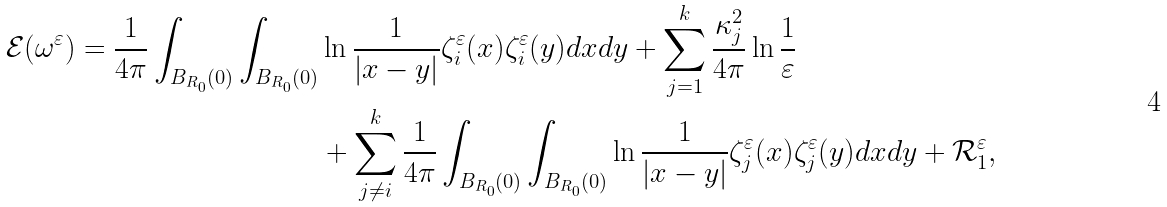Convert formula to latex. <formula><loc_0><loc_0><loc_500><loc_500>\mathcal { E } ( { \omega } ^ { \varepsilon } ) = \frac { 1 } { 4 \pi } \int _ { B _ { R _ { 0 } } ( 0 ) } \int _ { B _ { R _ { 0 } } ( 0 ) } & \ln \frac { 1 } { | x - y | } \zeta ^ { \varepsilon } _ { i } ( x ) \zeta ^ { \varepsilon } _ { i } ( y ) d x d y + \sum _ { j = 1 } ^ { k } \frac { \kappa _ { j } ^ { 2 } } { 4 \pi } \ln \frac { 1 } { \varepsilon } \\ & + \sum _ { j \not = i } ^ { k } \frac { 1 } { 4 \pi } \int _ { B _ { R _ { 0 } } ( 0 ) } \int _ { B _ { R _ { 0 } } ( 0 ) } \ln \frac { 1 } { | x - y | } \zeta ^ { \varepsilon } _ { j } ( x ) \zeta ^ { \varepsilon } _ { j } ( y ) d x d y + \mathcal { R } ^ { \varepsilon } _ { 1 } ,</formula> 